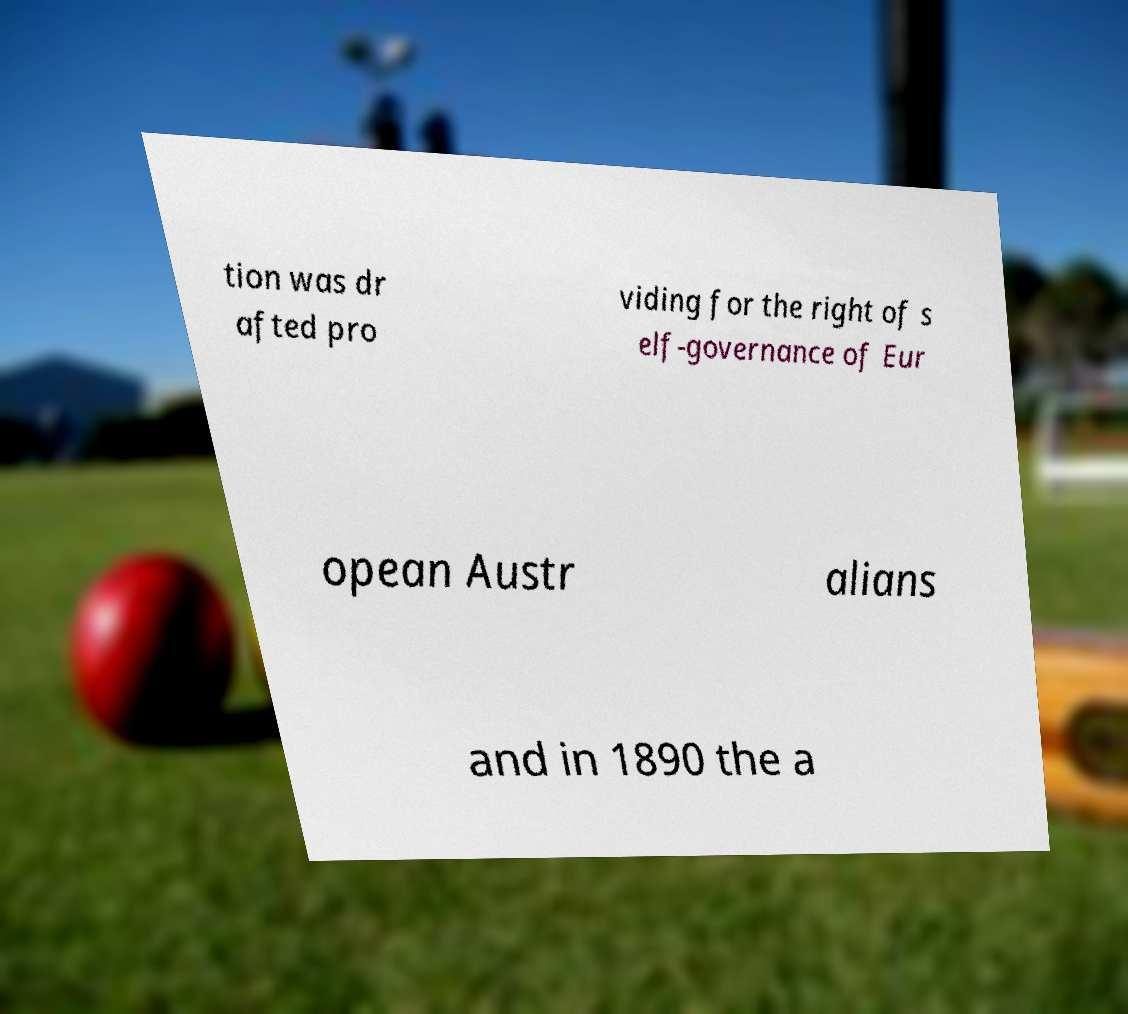Can you read and provide the text displayed in the image?This photo seems to have some interesting text. Can you extract and type it out for me? tion was dr afted pro viding for the right of s elf-governance of Eur opean Austr alians and in 1890 the a 